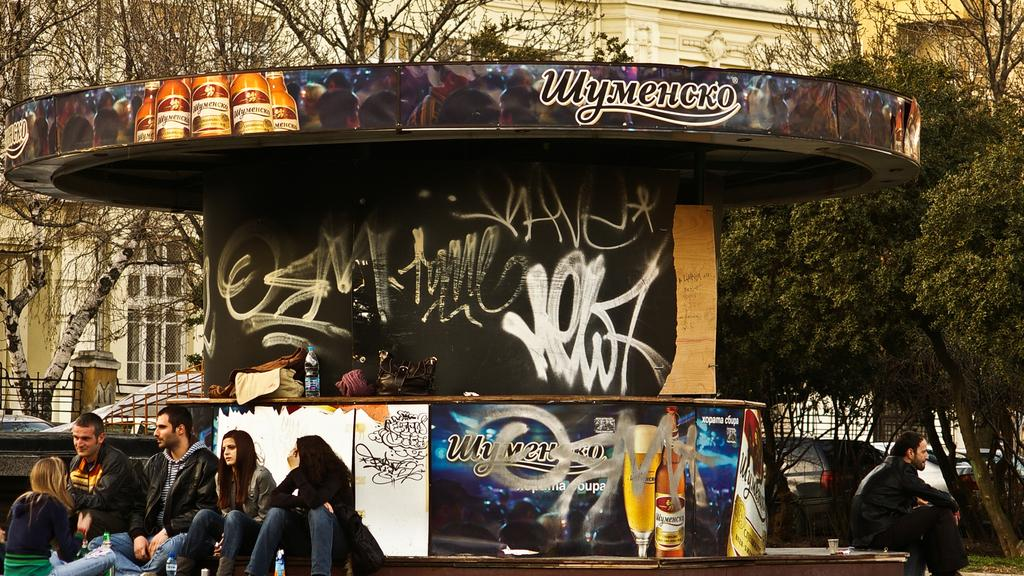How many people are in the image? There is a group of people in the image, but the exact number is not specified. What are the people doing in the image? The people are sitting in front of a counter. What can be seen on the counter? The counter has text and images on it. What is visible in the background of the image? There are buildings and trees in the background of the image. What type of box is being played by the person in the image? There is no box or person playing an instrument present in the image. What do you believe the people in the image are discussing? We cannot determine what the people in the image are discussing, as there is no information about their conversation. 